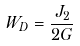Convert formula to latex. <formula><loc_0><loc_0><loc_500><loc_500>W _ { D } = \frac { J _ { 2 } } { 2 G }</formula> 